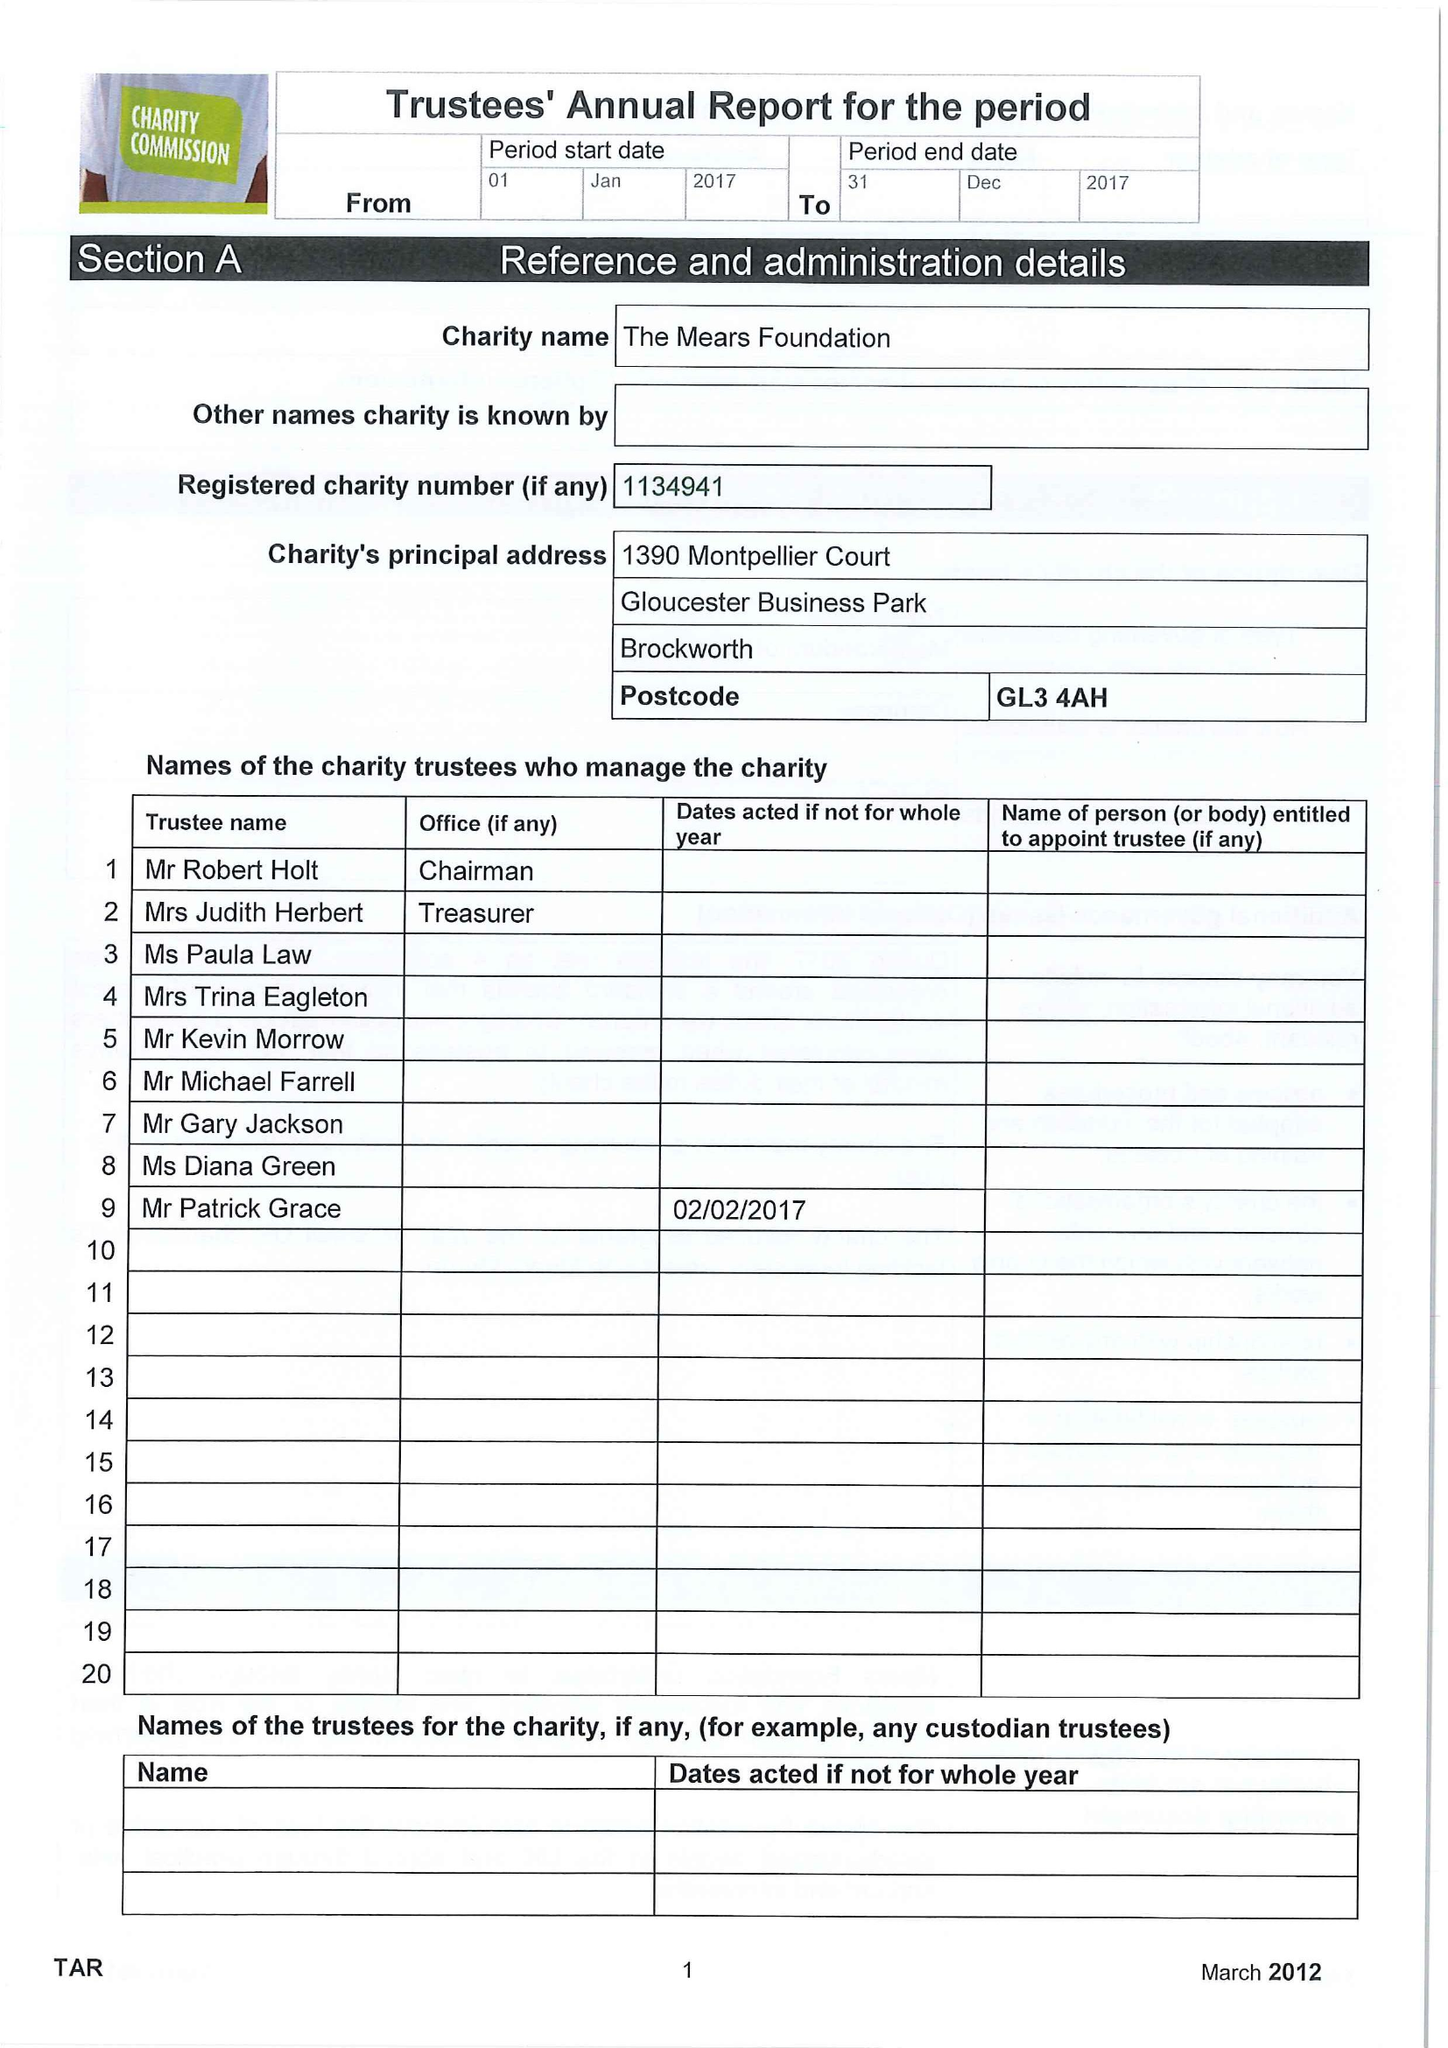What is the value for the charity_name?
Answer the question using a single word or phrase. The Mears Foundation 